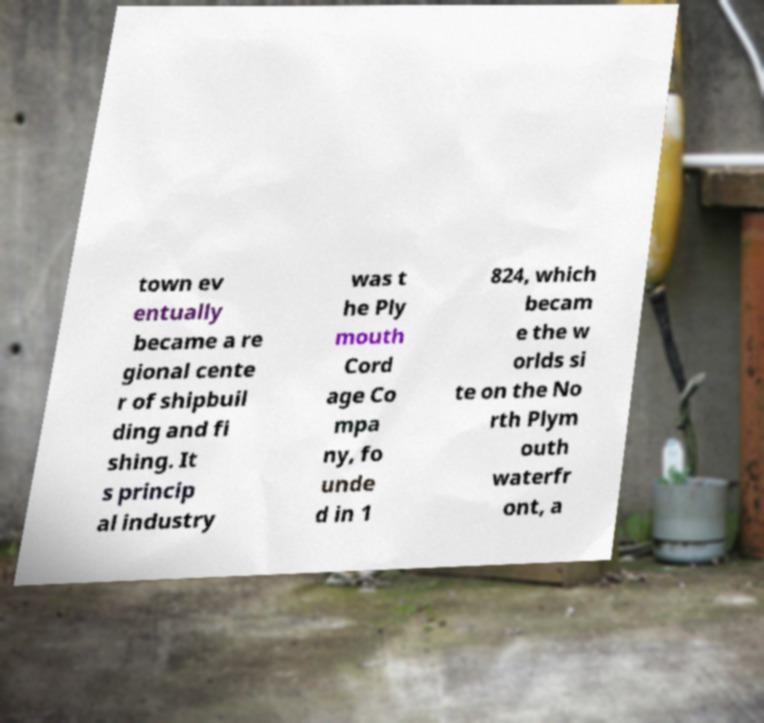Can you read and provide the text displayed in the image?This photo seems to have some interesting text. Can you extract and type it out for me? town ev entually became a re gional cente r of shipbuil ding and fi shing. It s princip al industry was t he Ply mouth Cord age Co mpa ny, fo unde d in 1 824, which becam e the w orlds si te on the No rth Plym outh waterfr ont, a 